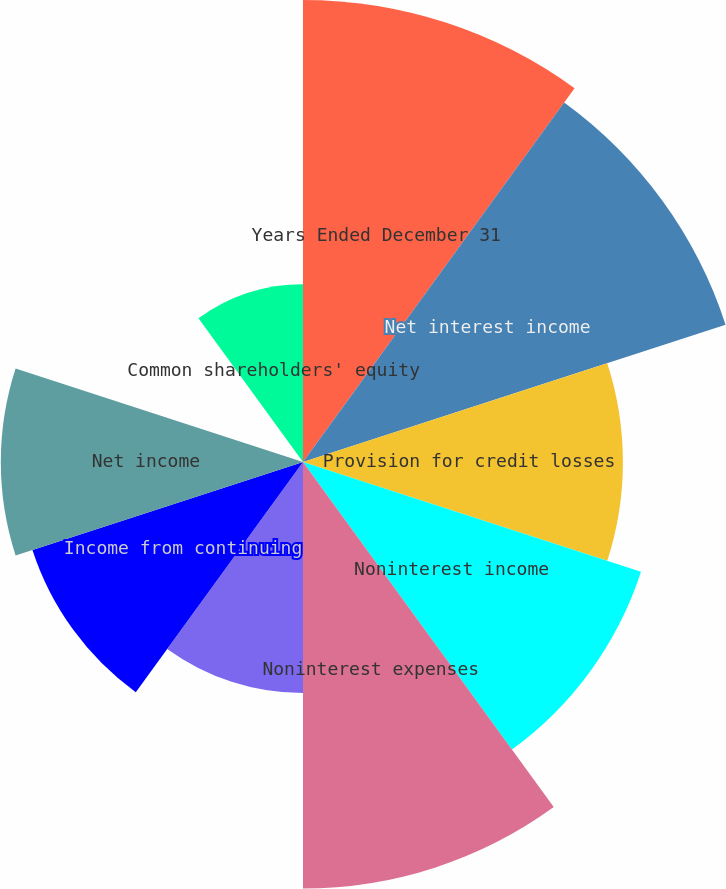Convert chart. <chart><loc_0><loc_0><loc_500><loc_500><pie_chart><fcel>Years Ended December 31<fcel>Net interest income<fcel>Provision for credit losses<fcel>Noninterest income<fcel>Noninterest expenses<fcel>Provision for income taxes<fcel>Income from continuing<fcel>Net income<fcel>Cash dividends declared<fcel>Common shareholders' equity<nl><fcel>15.38%<fcel>14.79%<fcel>10.65%<fcel>11.83%<fcel>14.2%<fcel>7.69%<fcel>9.47%<fcel>10.06%<fcel>0.0%<fcel>5.92%<nl></chart> 